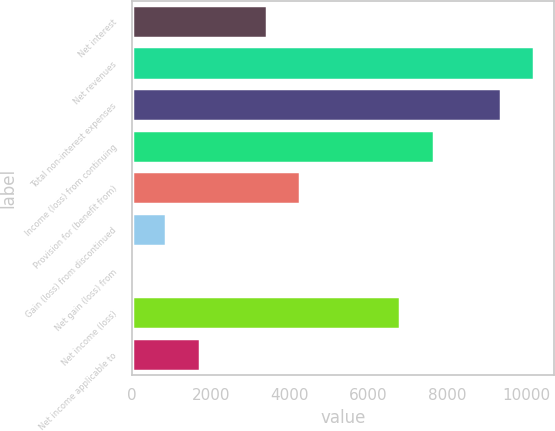Convert chart to OTSL. <chart><loc_0><loc_0><loc_500><loc_500><bar_chart><fcel>Net interest<fcel>Net revenues<fcel>Total non-interest expenses<fcel>Income (loss) from continuing<fcel>Provision for (benefit from)<fcel>Gain (loss) from discontinued<fcel>Net gain (loss) from<fcel>Net income (loss)<fcel>Net income applicable to<nl><fcel>3417.8<fcel>10195.4<fcel>9348.2<fcel>7653.8<fcel>4265<fcel>876.2<fcel>29<fcel>6806.6<fcel>1723.4<nl></chart> 